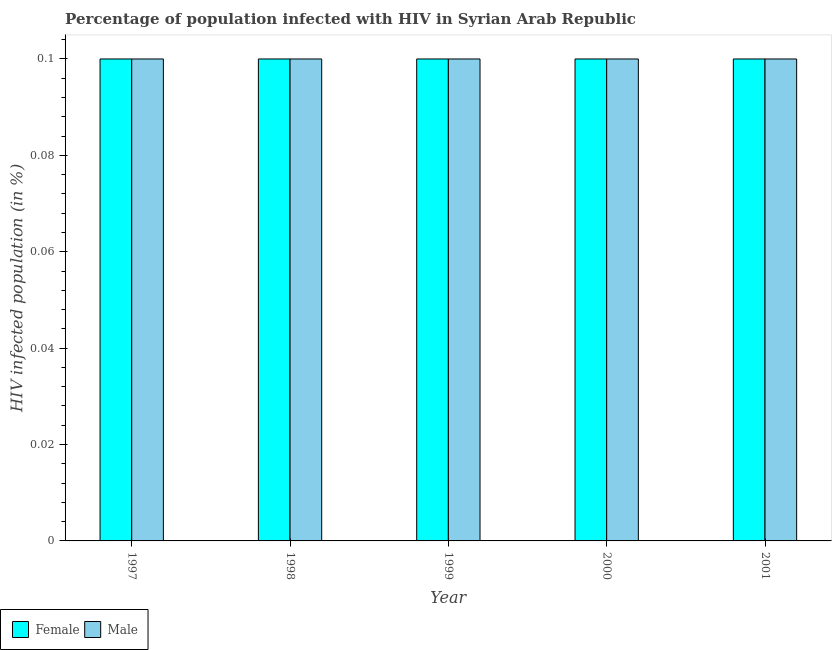How many different coloured bars are there?
Offer a very short reply. 2. Are the number of bars per tick equal to the number of legend labels?
Offer a terse response. Yes. Are the number of bars on each tick of the X-axis equal?
Keep it short and to the point. Yes. How many bars are there on the 5th tick from the left?
Give a very brief answer. 2. Across all years, what is the maximum percentage of males who are infected with hiv?
Provide a succinct answer. 0.1. In which year was the percentage of males who are infected with hiv maximum?
Offer a terse response. 1997. What is the total percentage of males who are infected with hiv in the graph?
Make the answer very short. 0.5. What is the difference between the percentage of females who are infected with hiv in 1998 and that in 2001?
Provide a short and direct response. 0. What is the difference between the percentage of females who are infected with hiv in 2000 and the percentage of males who are infected with hiv in 1998?
Your response must be concise. 0. In how many years, is the percentage of females who are infected with hiv greater than 0.076 %?
Give a very brief answer. 5. What is the ratio of the percentage of females who are infected with hiv in 1999 to that in 2001?
Make the answer very short. 1. Is the difference between the percentage of females who are infected with hiv in 1998 and 2000 greater than the difference between the percentage of males who are infected with hiv in 1998 and 2000?
Provide a succinct answer. No. In how many years, is the percentage of males who are infected with hiv greater than the average percentage of males who are infected with hiv taken over all years?
Your answer should be very brief. 0. Is the sum of the percentage of females who are infected with hiv in 1998 and 1999 greater than the maximum percentage of males who are infected with hiv across all years?
Your answer should be very brief. Yes. How many bars are there?
Ensure brevity in your answer.  10. Are all the bars in the graph horizontal?
Offer a very short reply. No. How many years are there in the graph?
Your answer should be very brief. 5. Are the values on the major ticks of Y-axis written in scientific E-notation?
Your response must be concise. No. Does the graph contain any zero values?
Ensure brevity in your answer.  No. Does the graph contain grids?
Give a very brief answer. No. Where does the legend appear in the graph?
Your answer should be very brief. Bottom left. How are the legend labels stacked?
Your response must be concise. Horizontal. What is the title of the graph?
Ensure brevity in your answer.  Percentage of population infected with HIV in Syrian Arab Republic. What is the label or title of the Y-axis?
Your answer should be compact. HIV infected population (in %). What is the HIV infected population (in %) of Female in 1999?
Offer a very short reply. 0.1. What is the HIV infected population (in %) of Female in 2000?
Make the answer very short. 0.1. What is the HIV infected population (in %) of Male in 2000?
Provide a succinct answer. 0.1. What is the HIV infected population (in %) in Male in 2001?
Provide a succinct answer. 0.1. Across all years, what is the maximum HIV infected population (in %) in Male?
Offer a terse response. 0.1. Across all years, what is the minimum HIV infected population (in %) of Male?
Your response must be concise. 0.1. What is the total HIV infected population (in %) in Female in the graph?
Provide a succinct answer. 0.5. What is the difference between the HIV infected population (in %) of Female in 1997 and that in 1998?
Offer a terse response. 0. What is the difference between the HIV infected population (in %) of Female in 1997 and that in 1999?
Make the answer very short. 0. What is the difference between the HIV infected population (in %) of Male in 1997 and that in 1999?
Provide a succinct answer. 0. What is the difference between the HIV infected population (in %) in Female in 1997 and that in 2000?
Keep it short and to the point. 0. What is the difference between the HIV infected population (in %) in Female in 1998 and that in 1999?
Give a very brief answer. 0. What is the difference between the HIV infected population (in %) of Male in 1998 and that in 1999?
Offer a very short reply. 0. What is the difference between the HIV infected population (in %) of Female in 1998 and that in 2001?
Offer a very short reply. 0. What is the difference between the HIV infected population (in %) in Male in 1999 and that in 2000?
Ensure brevity in your answer.  0. What is the difference between the HIV infected population (in %) in Female in 1999 and that in 2001?
Offer a terse response. 0. What is the difference between the HIV infected population (in %) of Female in 2000 and that in 2001?
Your answer should be very brief. 0. What is the difference between the HIV infected population (in %) of Male in 2000 and that in 2001?
Offer a very short reply. 0. What is the difference between the HIV infected population (in %) in Female in 1997 and the HIV infected population (in %) in Male in 1998?
Keep it short and to the point. 0. What is the difference between the HIV infected population (in %) in Female in 1997 and the HIV infected population (in %) in Male in 1999?
Your response must be concise. 0. What is the difference between the HIV infected population (in %) in Female in 1998 and the HIV infected population (in %) in Male in 1999?
Offer a terse response. 0. What is the difference between the HIV infected population (in %) of Female in 1998 and the HIV infected population (in %) of Male in 2001?
Offer a terse response. 0. What is the difference between the HIV infected population (in %) of Female in 2000 and the HIV infected population (in %) of Male in 2001?
Ensure brevity in your answer.  0. What is the average HIV infected population (in %) of Male per year?
Offer a terse response. 0.1. In the year 1998, what is the difference between the HIV infected population (in %) of Female and HIV infected population (in %) of Male?
Your answer should be very brief. 0. In the year 1999, what is the difference between the HIV infected population (in %) in Female and HIV infected population (in %) in Male?
Your answer should be very brief. 0. In the year 2000, what is the difference between the HIV infected population (in %) of Female and HIV infected population (in %) of Male?
Ensure brevity in your answer.  0. What is the ratio of the HIV infected population (in %) of Female in 1997 to that in 1998?
Your answer should be compact. 1. What is the ratio of the HIV infected population (in %) in Male in 1997 to that in 1998?
Make the answer very short. 1. What is the ratio of the HIV infected population (in %) of Female in 1997 to that in 2000?
Your response must be concise. 1. What is the ratio of the HIV infected population (in %) in Male in 1997 to that in 2001?
Provide a short and direct response. 1. What is the ratio of the HIV infected population (in %) of Female in 1998 to that in 1999?
Your answer should be compact. 1. What is the ratio of the HIV infected population (in %) in Male in 1998 to that in 1999?
Provide a short and direct response. 1. What is the ratio of the HIV infected population (in %) of Male in 1998 to that in 2000?
Make the answer very short. 1. What is the ratio of the HIV infected population (in %) of Female in 1998 to that in 2001?
Your answer should be very brief. 1. What is the ratio of the HIV infected population (in %) in Male in 1999 to that in 2000?
Provide a succinct answer. 1. What is the ratio of the HIV infected population (in %) of Female in 1999 to that in 2001?
Provide a succinct answer. 1. What is the ratio of the HIV infected population (in %) of Male in 2000 to that in 2001?
Make the answer very short. 1. What is the difference between the highest and the second highest HIV infected population (in %) of Female?
Ensure brevity in your answer.  0. What is the difference between the highest and the second highest HIV infected population (in %) in Male?
Ensure brevity in your answer.  0. What is the difference between the highest and the lowest HIV infected population (in %) in Female?
Provide a succinct answer. 0. 